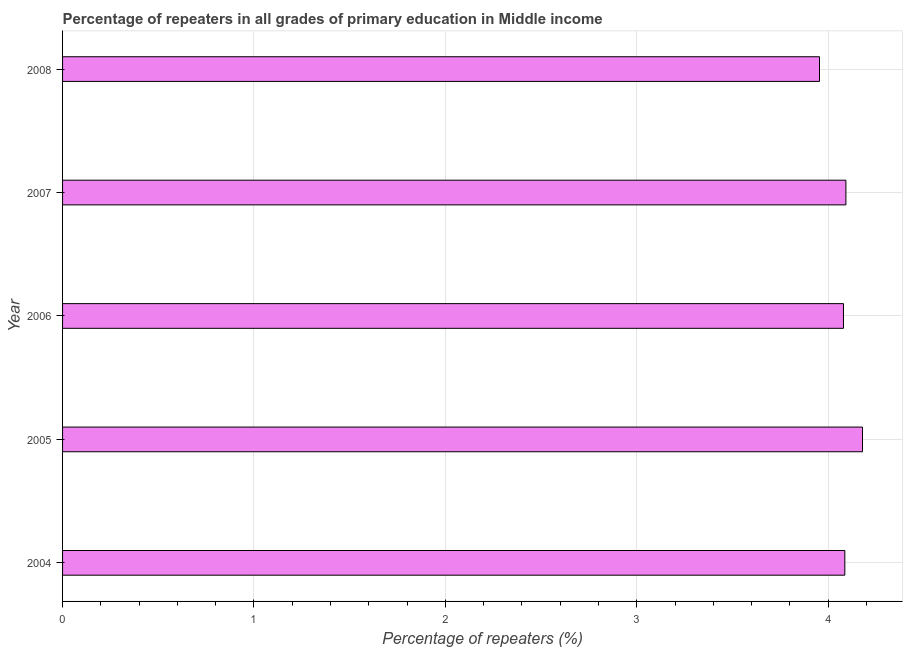What is the title of the graph?
Ensure brevity in your answer.  Percentage of repeaters in all grades of primary education in Middle income. What is the label or title of the X-axis?
Keep it short and to the point. Percentage of repeaters (%). What is the percentage of repeaters in primary education in 2005?
Provide a short and direct response. 4.18. Across all years, what is the maximum percentage of repeaters in primary education?
Ensure brevity in your answer.  4.18. Across all years, what is the minimum percentage of repeaters in primary education?
Offer a very short reply. 3.95. What is the sum of the percentage of repeaters in primary education?
Offer a very short reply. 20.39. What is the difference between the percentage of repeaters in primary education in 2005 and 2008?
Offer a terse response. 0.23. What is the average percentage of repeaters in primary education per year?
Provide a short and direct response. 4.08. What is the median percentage of repeaters in primary education?
Ensure brevity in your answer.  4.09. What is the ratio of the percentage of repeaters in primary education in 2007 to that in 2008?
Your answer should be very brief. 1.03. What is the difference between the highest and the second highest percentage of repeaters in primary education?
Offer a very short reply. 0.09. Is the sum of the percentage of repeaters in primary education in 2004 and 2007 greater than the maximum percentage of repeaters in primary education across all years?
Provide a short and direct response. Yes. What is the difference between the highest and the lowest percentage of repeaters in primary education?
Keep it short and to the point. 0.22. Are all the bars in the graph horizontal?
Give a very brief answer. Yes. How many years are there in the graph?
Your answer should be compact. 5. What is the difference between two consecutive major ticks on the X-axis?
Your response must be concise. 1. Are the values on the major ticks of X-axis written in scientific E-notation?
Provide a succinct answer. No. What is the Percentage of repeaters (%) in 2004?
Ensure brevity in your answer.  4.09. What is the Percentage of repeaters (%) of 2005?
Give a very brief answer. 4.18. What is the Percentage of repeaters (%) in 2006?
Make the answer very short. 4.08. What is the Percentage of repeaters (%) of 2007?
Keep it short and to the point. 4.09. What is the Percentage of repeaters (%) in 2008?
Offer a terse response. 3.95. What is the difference between the Percentage of repeaters (%) in 2004 and 2005?
Make the answer very short. -0.09. What is the difference between the Percentage of repeaters (%) in 2004 and 2006?
Your answer should be very brief. 0.01. What is the difference between the Percentage of repeaters (%) in 2004 and 2007?
Provide a succinct answer. -0.01. What is the difference between the Percentage of repeaters (%) in 2004 and 2008?
Your answer should be very brief. 0.13. What is the difference between the Percentage of repeaters (%) in 2005 and 2006?
Give a very brief answer. 0.1. What is the difference between the Percentage of repeaters (%) in 2005 and 2007?
Keep it short and to the point. 0.09. What is the difference between the Percentage of repeaters (%) in 2005 and 2008?
Your answer should be very brief. 0.22. What is the difference between the Percentage of repeaters (%) in 2006 and 2007?
Give a very brief answer. -0.01. What is the difference between the Percentage of repeaters (%) in 2006 and 2008?
Give a very brief answer. 0.13. What is the difference between the Percentage of repeaters (%) in 2007 and 2008?
Provide a succinct answer. 0.14. What is the ratio of the Percentage of repeaters (%) in 2004 to that in 2005?
Your answer should be compact. 0.98. What is the ratio of the Percentage of repeaters (%) in 2004 to that in 2007?
Give a very brief answer. 1. What is the ratio of the Percentage of repeaters (%) in 2004 to that in 2008?
Offer a terse response. 1.03. What is the ratio of the Percentage of repeaters (%) in 2005 to that in 2006?
Offer a very short reply. 1.02. What is the ratio of the Percentage of repeaters (%) in 2005 to that in 2007?
Your answer should be compact. 1.02. What is the ratio of the Percentage of repeaters (%) in 2005 to that in 2008?
Keep it short and to the point. 1.06. What is the ratio of the Percentage of repeaters (%) in 2006 to that in 2008?
Offer a terse response. 1.03. What is the ratio of the Percentage of repeaters (%) in 2007 to that in 2008?
Your answer should be very brief. 1.03. 